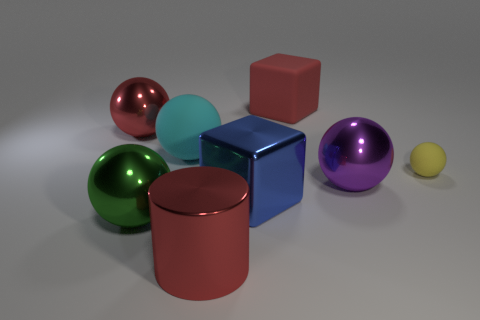Is the number of big metal balls less than the number of small brown metal cylinders?
Make the answer very short. No. What material is the blue cube that is the same size as the red ball?
Make the answer very short. Metal. How many objects are yellow objects or large yellow metallic cylinders?
Provide a short and direct response. 1. How many shiny objects are both in front of the big metal cube and on the right side of the green metallic thing?
Provide a short and direct response. 1. Are there fewer small things left of the large red metal ball than big blue metal blocks?
Your response must be concise. Yes. There is a purple object that is the same size as the green shiny sphere; what is its shape?
Offer a very short reply. Sphere. What number of other things are the same color as the large shiny block?
Provide a succinct answer. 0. Does the rubber cube have the same size as the yellow ball?
Offer a terse response. No. What number of objects are big green matte cylinders or large spheres that are to the left of the large red cylinder?
Make the answer very short. 3. Is the number of big matte blocks that are in front of the big red metallic cylinder less than the number of rubber balls that are right of the large cyan sphere?
Your answer should be compact. Yes. 